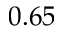Convert formula to latex. <formula><loc_0><loc_0><loc_500><loc_500>0 . 6 5</formula> 